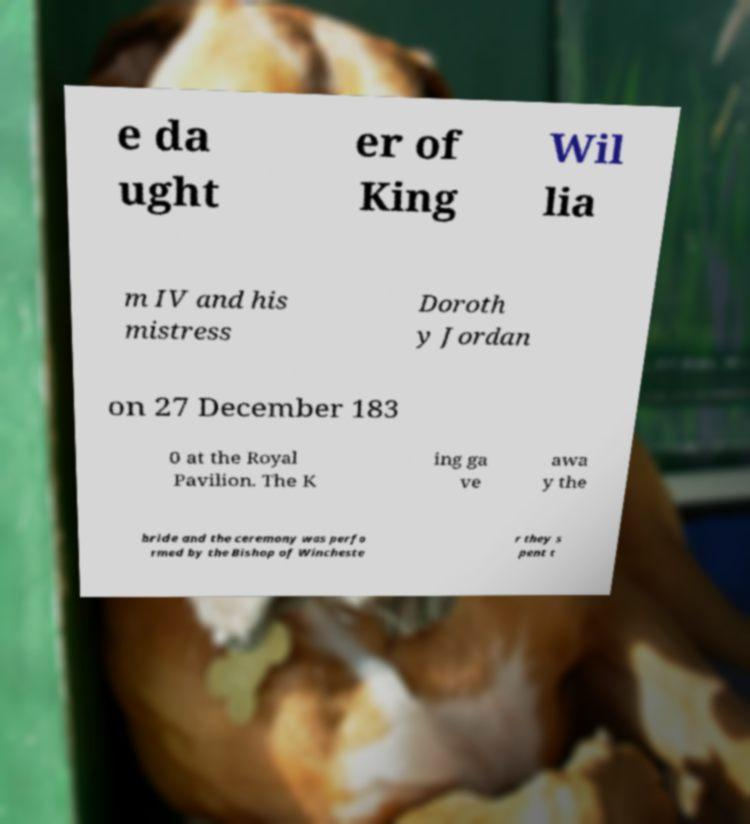Could you extract and type out the text from this image? e da ught er of King Wil lia m IV and his mistress Doroth y Jordan on 27 December 183 0 at the Royal Pavilion. The K ing ga ve awa y the bride and the ceremony was perfo rmed by the Bishop of Wincheste r they s pent t 